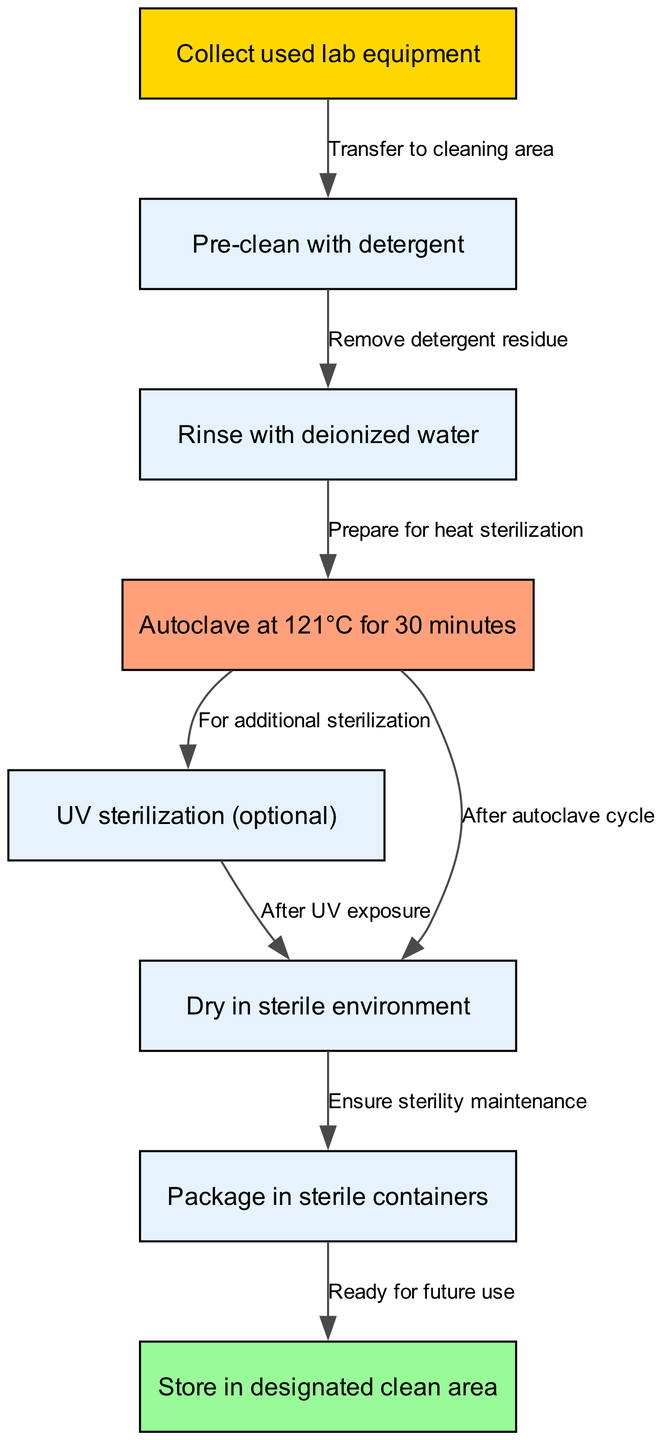What is the first step in the sterilization process? The diagram indicates that the first step is to "Collect used lab equipment," which is represented as node 1.
Answer: Collect used lab equipment How many steps are there in total? By counting the nodes in the diagram, we see there are 8 distinct steps listed, as shown in the nodes section.
Answer: 8 What is the relationship between rinsing with deionized water and autoclaving? The diagram shows that rinsing with deionized water (node 3) is a step that directly leads to preparing for heat sterilization, which is autoclaving (node 4). Thus, rinsing is a preparatory step for autoclaving.
Answer: Prepare for heat sterilization What happens after autoclaving? After the autoclave cycle (node 4), the diagram indicates two options: it can lead to UV sterilization (node 5) for additional sterilization, or to drying in a sterile environment (node 6). This choice illustrates that there are alternative paths based on needs.
Answer: UV sterilization or Dry in sterile environment What must be ensured before packaging the equipment? The diagram highlights that before the equipment can be packaged in sterile containers (node 7), one must ensure sterility maintenance after drying in a sterile environment (node 6). This is critical to retain sterility.
Answer: Ensure sterility maintenance What is the last step in the sterilization process? The final step illustrated in the diagram is "Store in designated clean area," which is represented as node 8. It is directly connected to the previous step of packaging.
Answer: Store in designated clean area Is UV sterilization mandatory? According to the diagram, UV sterilization (node 5) is marked as optional as it branches off after the autoclaving step. This implies that it is not a mandatory procedure within the sterilization process.
Answer: Optional How does one prepare the equipment before autoclaving? The flow indicates that one must first rinse with deionized water after pre-cleaning with detergent to prepare the equipment for the autoclaving step. This sequence is shown by the edges connecting the nodes.
Answer: Rinse with deionized water 